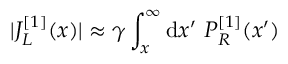Convert formula to latex. <formula><loc_0><loc_0><loc_500><loc_500>| J _ { L } ^ { [ 1 ] } ( x ) | \approx \gamma \int _ { x } ^ { \infty } d x ^ { \prime } P _ { R } ^ { [ 1 ] } ( x ^ { \prime } )</formula> 